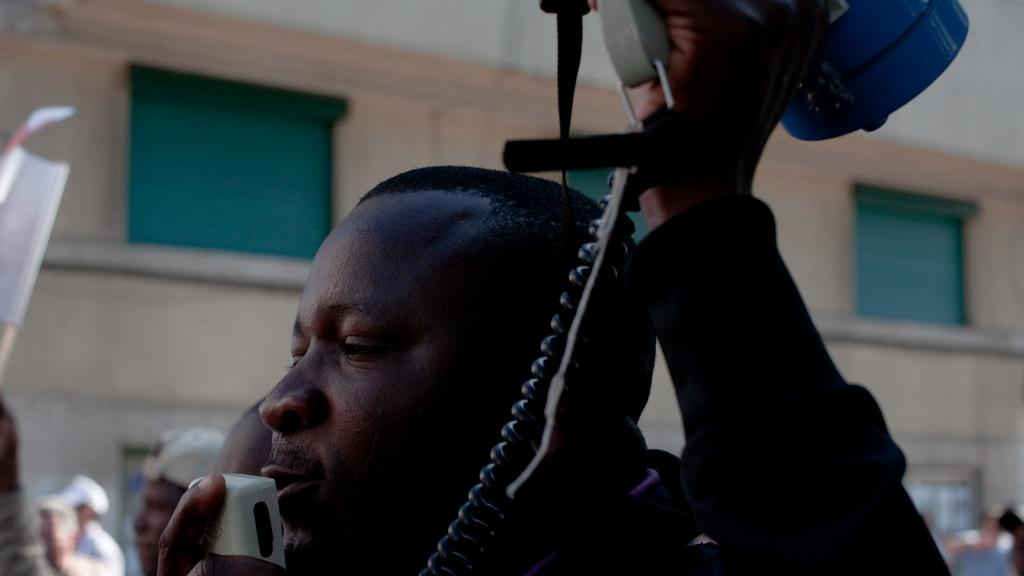Who is present in the image? There is a man in the image. What is the man holding in his hands? The man is holding a speaker and a mic. What can be seen in the background of the image? There is a building in the background of the image. What type of powder is being used by the man in the image? There is no powder present in the image; the man is holding a speaker and a mic. 